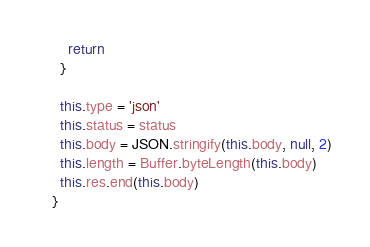Convert code to text. <code><loc_0><loc_0><loc_500><loc_500><_JavaScript_>    return
  }

  this.type = 'json'
  this.status = status
  this.body = JSON.stringify(this.body, null, 2)
  this.length = Buffer.byteLength(this.body)
  this.res.end(this.body)
}
</code> 